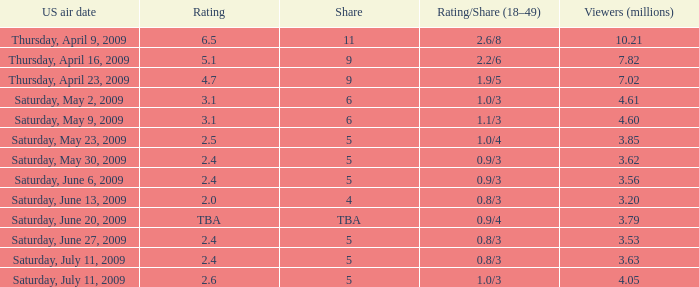What is the lowest numbered episode that had a rating/share of 0.9/4 and more than 3.79 million viewers? None. 